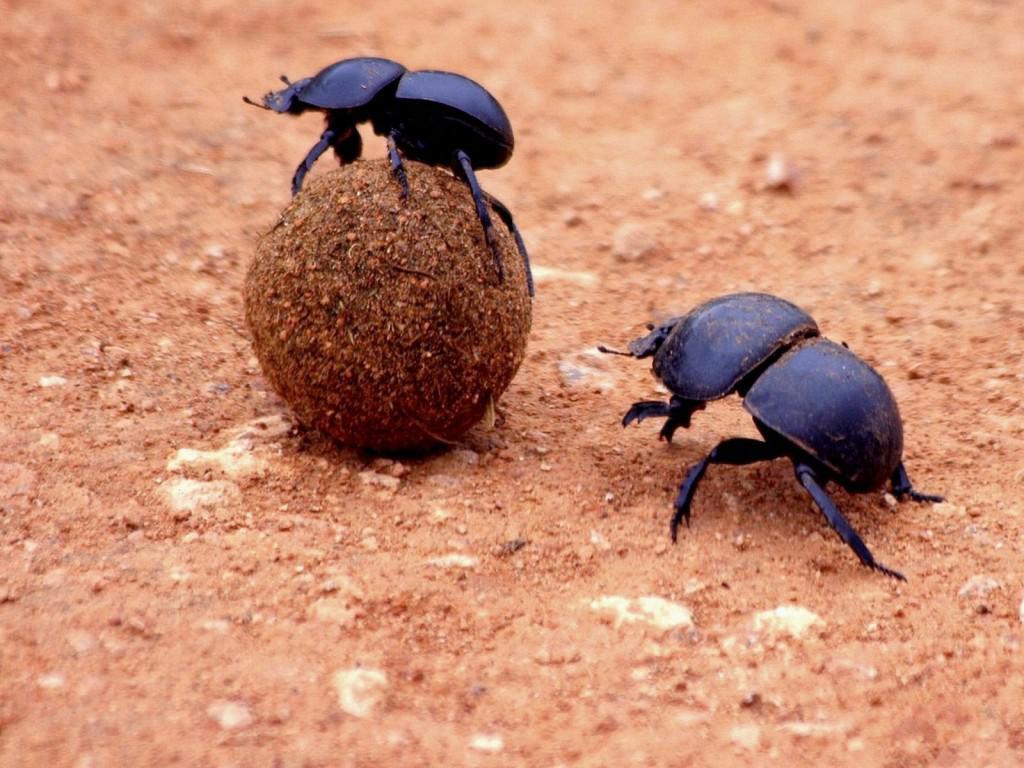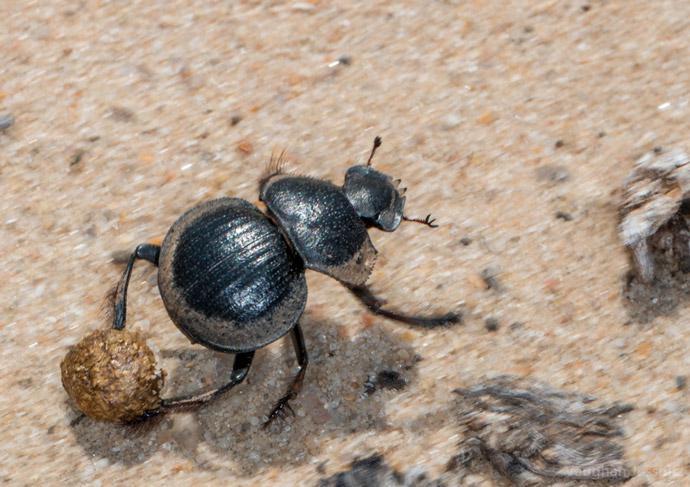The first image is the image on the left, the second image is the image on the right. Assess this claim about the two images: "There are only two beetles touching a dungball in the right image". Correct or not? Answer yes or no. No. The first image is the image on the left, the second image is the image on the right. Assess this claim about the two images: "An image shows beetles on the left and right of one dungball, and each beetle is in contact with the ball.". Correct or not? Answer yes or no. No. 